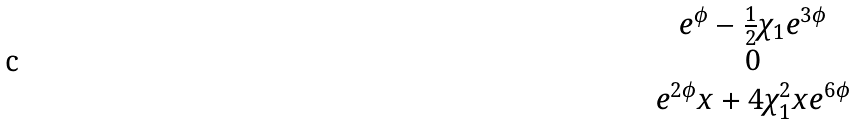<formula> <loc_0><loc_0><loc_500><loc_500>\begin{matrix} e ^ { \phi } - \frac { 1 } { 2 } \chi _ { 1 } e ^ { 3 \phi } \\ 0 \\ e ^ { 2 \phi } x + 4 \chi _ { 1 } ^ { 2 } x e ^ { 6 \phi } \\ \end{matrix}</formula> 